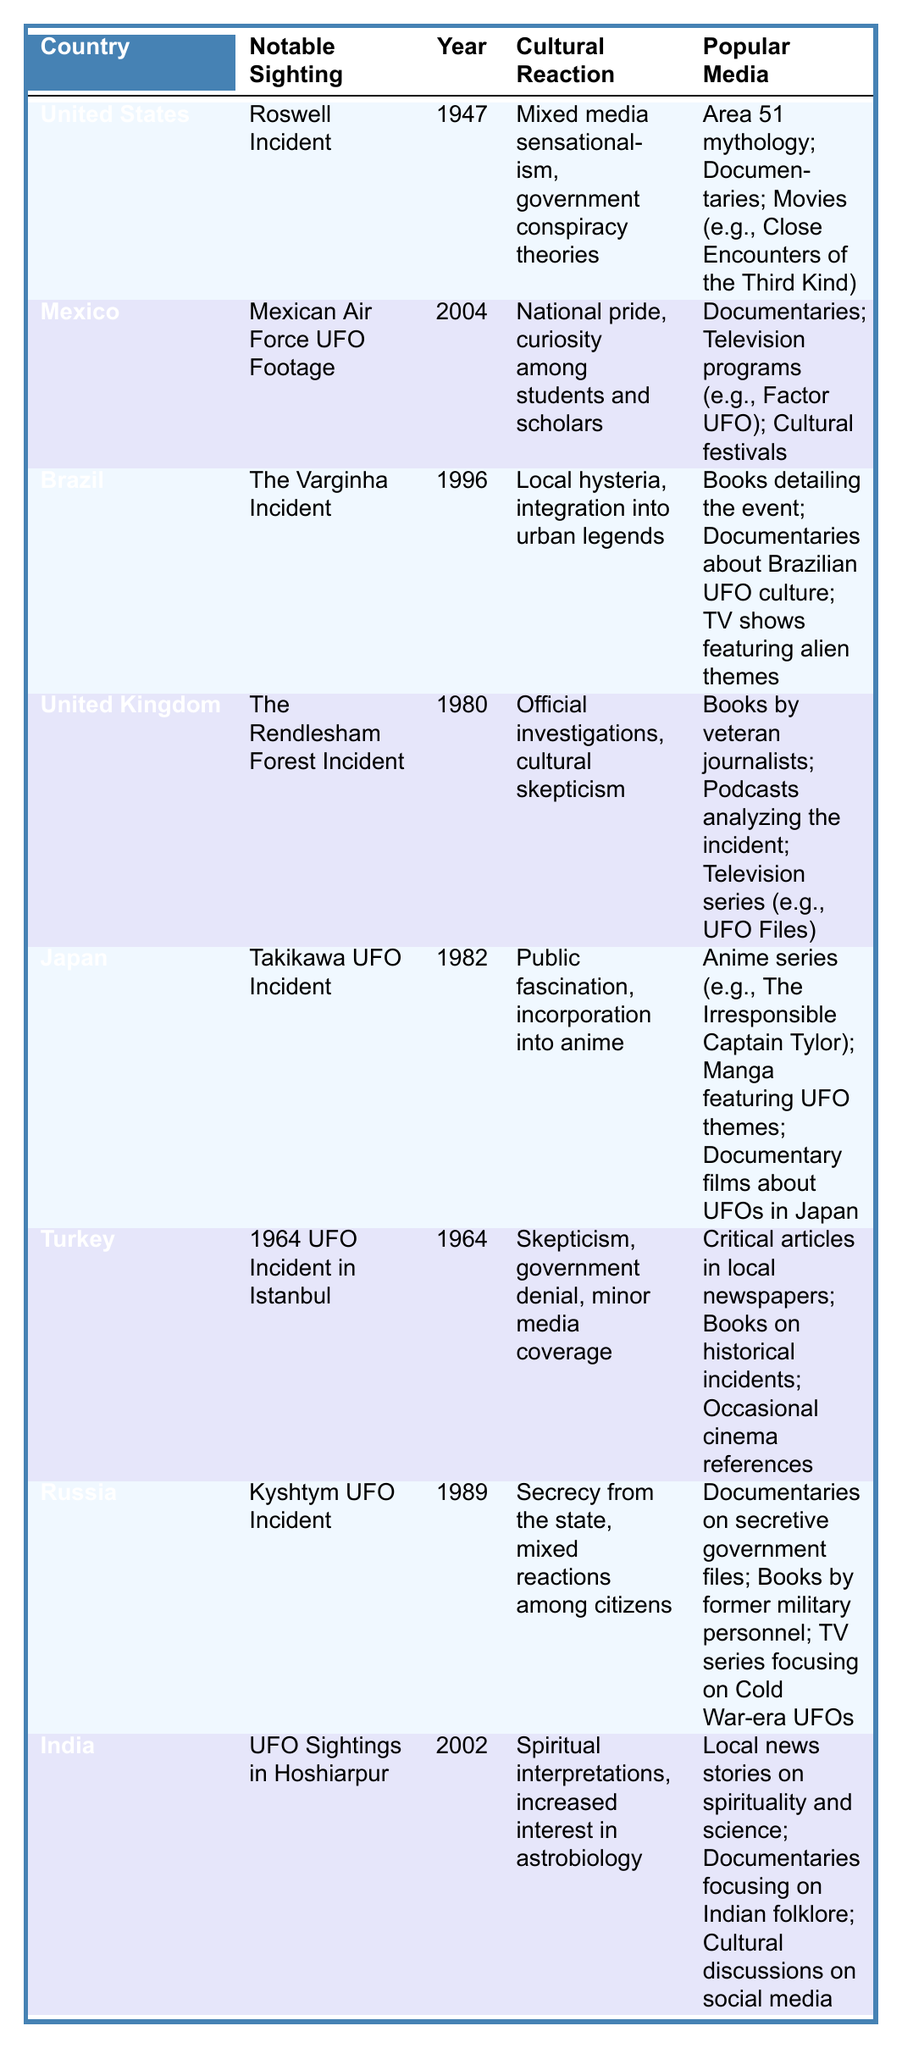What was the cultural reaction to the Roswell Incident in the United States? According to the table, the cultural reaction in the United States to the Roswell Incident included mixed media sensationalism and government conspiracy theories.
Answer: Mixed media sensationalism, government conspiracy theories Which country experienced local hysteria due to a UFO sighting and what was that sighting? The table indicates that Brazil experienced local hysteria due to the Varginha Incident in 1996.
Answer: Brazil; Varginha Incident How many years apart were the UFO sightings in Turkey and Russia? The sighting in Turkey occurred in 1964 and in Russia in 1989. The difference in years is 1989 - 1964 = 25 years.
Answer: 25 years What notable sighting occurred in Japan and what year did it happen? As per the table, the notable sighting in Japan was the Takikawa UFO Incident, which happened in 1982.
Answer: Takikawa UFO Incident; 1982 Did any country display national pride in their UFO sighting? Yes, according to the table, Mexico showed national pride in reaction to their UFO sighting (Mexican Air Force UFO Footage).
Answer: Yes Which cultural reaction was observed in the United Kingdom to their notable UFO sighting? The table states that the cultural reaction in the United Kingdom to the Rendlesham Forest Incident included official investigations and cultural skepticism.
Answer: Official investigations, cultural skepticism Identify the popular media related to the Varginha Incident in Brazil. The table lists the popular media related to the Varginha Incident as books detailing the event, documentaries about Brazilian UFO culture, and TV shows featuring alien themes.
Answer: Books, documentaries, TV shows What is the difference in cultural reactions between the United States and Turkey regarding UFO sightings? In the United States, the reaction involved mixed media sensationalism and government conspiracy theories, while in Turkey there was skepticism, government denial, and minor media coverage. This indicates a significantly less intense cultural reaction in Turkey.
Answer: United States: mixed media sensationalism, government conspiracy; Turkey: skepticism, government denial How did cultural reactions to UFO sightings in India reflect spiritual interpretations? The table shows that in India, UFO sightings were interpreted spiritually and led to increased interest in astrobiology, indicating a unique cultural perspective compared to other countries.
Answer: Spiritual interpretations, interest in astrobiology Which country had official investigations related to their notable UFO sighting? The table reveals that the United Kingdom had official investigations concerning the Rendlesham Forest Incident in 1980.
Answer: United Kingdom 